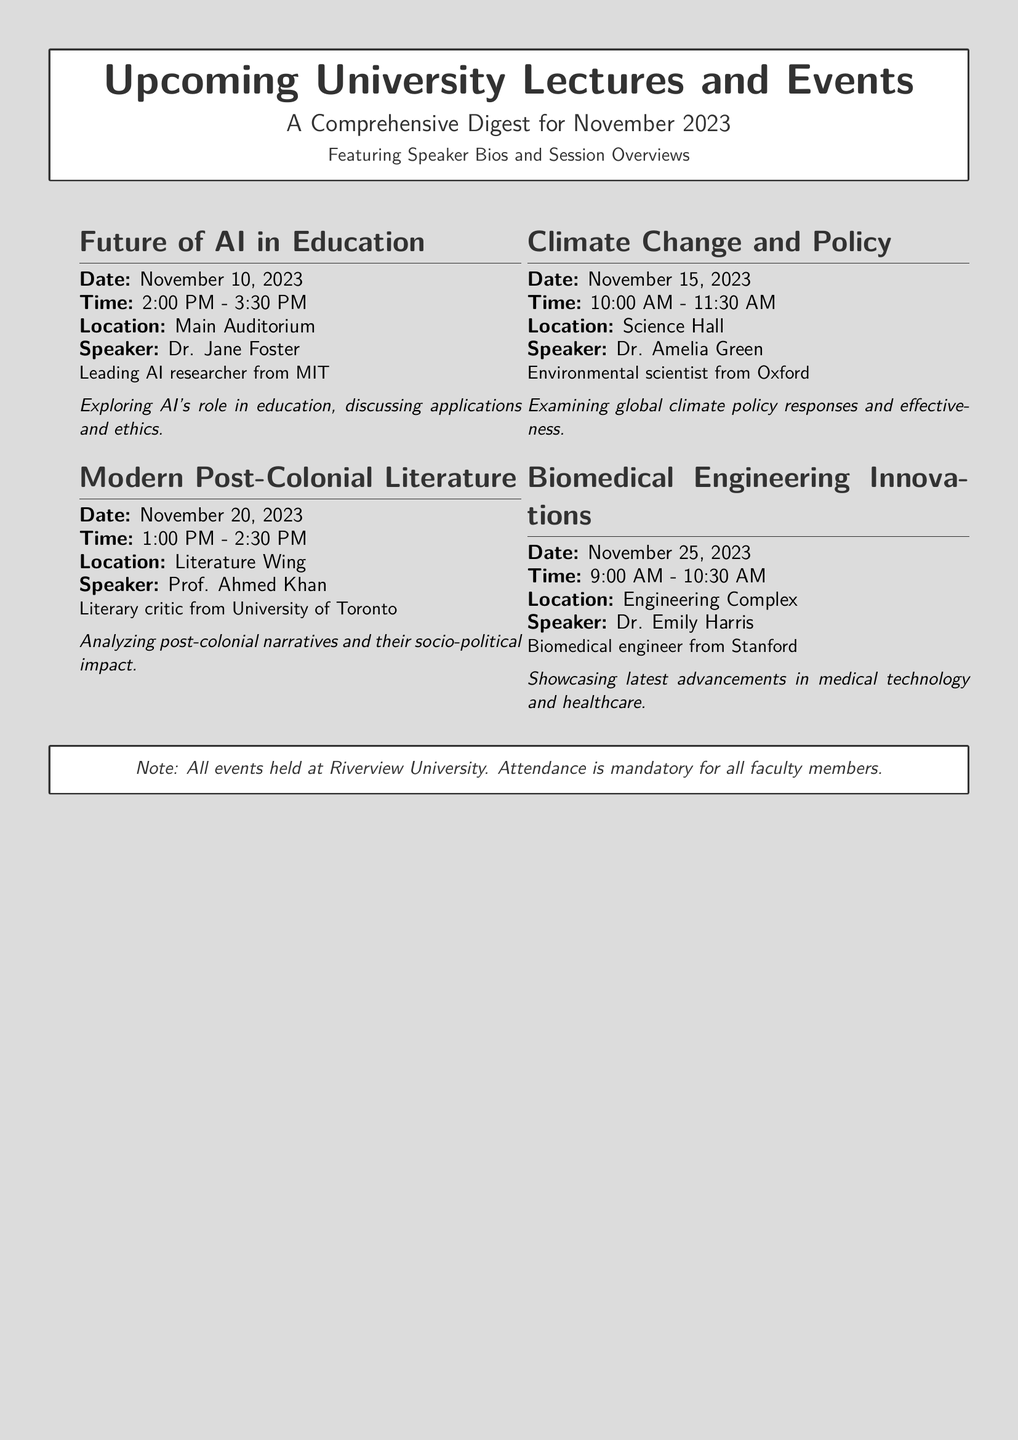What is the date of the first lecture? The first lecture titled "Future of AI in Education" is scheduled for November 10, 2023.
Answer: November 10, 2023 Who is the speaker for the lecture on climate change? The speaker for the "Climate Change and Policy" lecture is Dr. Amelia Green, an environmental scientist from Oxford.
Answer: Dr. Amelia Green What time does the "Modern Post-Colonial Literature" lecture start? The "Modern Post-Colonial Literature" lecture begins at 1:00 PM on November 20, 2023.
Answer: 1:00 PM Which location hosts the "Biomedical Engineering Innovations" lecture? The "Biomedical Engineering Innovations" lecture is held at the Engineering Complex.
Answer: Engineering Complex How many events are mentioned in the document? The document lists four events for November 2023.
Answer: Four What is a common theme across the lectures? All lectures cover contemporary issues relevant to technology, environment, literature, and biomedical fields.
Answer: Contemporary issues What is mandatory for all faculty members? Attendance at all events held at Riverview University is mandatory for all faculty members.
Answer: Attendance Which university is Dr. Emily Harris from? Dr. Emily Harris is a biomedical engineer from Stanford University.
Answer: Stanford What is the title of the second lecture? The title of the second lecture is "Climate Change and Policy".
Answer: Climate Change and Policy What type of content does Dr. Jane Foster's lecture focus on? Dr. Jane Foster's lecture focuses on AI's role in education, including applications and ethics.
Answer: AI's role in education 